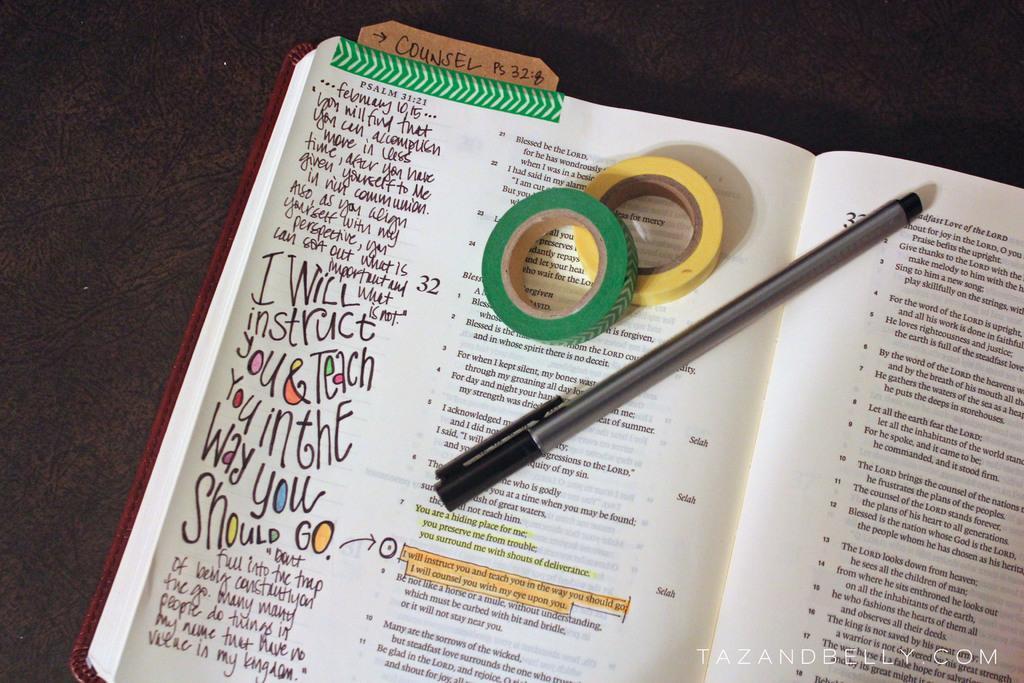How would you summarize this image in a sentence or two? In this image there is a book, bench and tapes are on the dark surface. Something is written in the book. At the bottom right side of the image there is a watermark.   